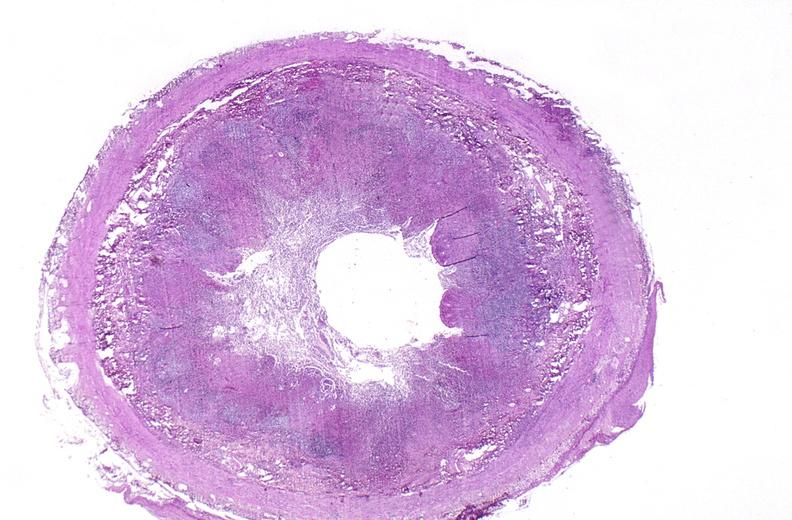s gangrene toe in infant present?
Answer the question using a single word or phrase. No 